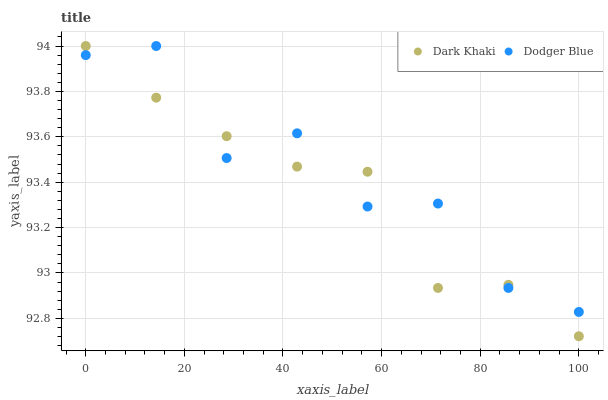Does Dark Khaki have the minimum area under the curve?
Answer yes or no. Yes. Does Dodger Blue have the maximum area under the curve?
Answer yes or no. Yes. Does Dodger Blue have the minimum area under the curve?
Answer yes or no. No. Is Dark Khaki the smoothest?
Answer yes or no. Yes. Is Dodger Blue the roughest?
Answer yes or no. Yes. Is Dodger Blue the smoothest?
Answer yes or no. No. Does Dark Khaki have the lowest value?
Answer yes or no. Yes. Does Dodger Blue have the lowest value?
Answer yes or no. No. Does Dodger Blue have the highest value?
Answer yes or no. Yes. Does Dodger Blue intersect Dark Khaki?
Answer yes or no. Yes. Is Dodger Blue less than Dark Khaki?
Answer yes or no. No. Is Dodger Blue greater than Dark Khaki?
Answer yes or no. No. 